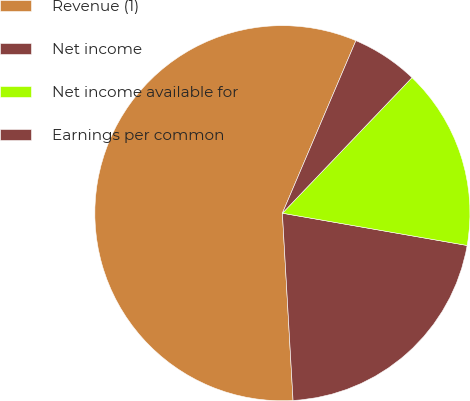Convert chart. <chart><loc_0><loc_0><loc_500><loc_500><pie_chart><fcel>Revenue (1)<fcel>Net income<fcel>Net income available for<fcel>Earnings per common<nl><fcel>57.31%<fcel>21.34%<fcel>15.61%<fcel>5.73%<nl></chart> 